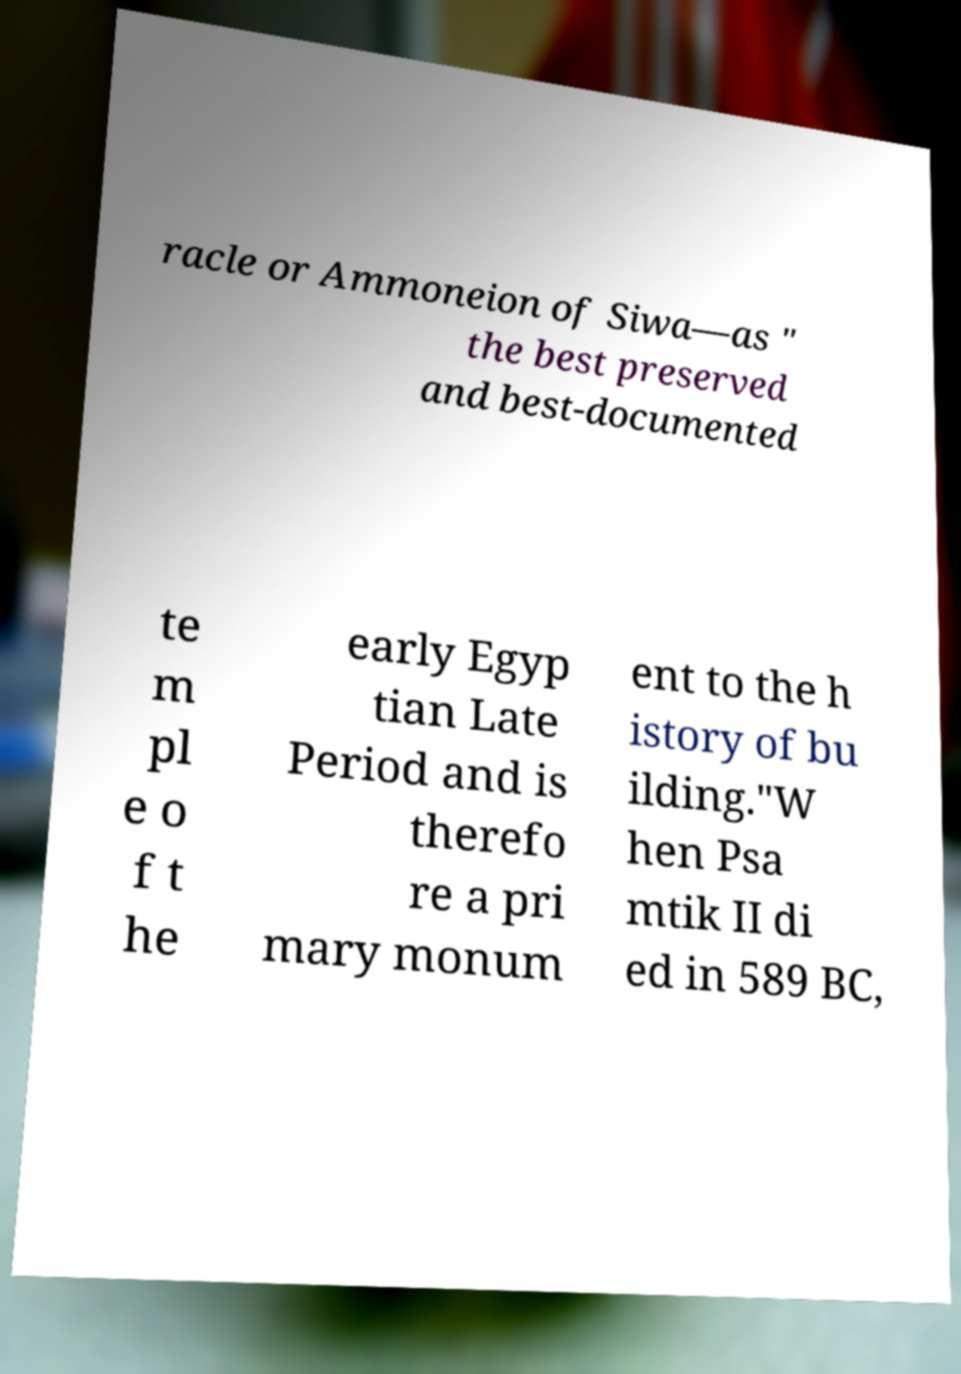Could you assist in decoding the text presented in this image and type it out clearly? racle or Ammoneion of Siwa—as " the best preserved and best-documented te m pl e o f t he early Egyp tian Late Period and is therefo re a pri mary monum ent to the h istory of bu ilding."W hen Psa mtik II di ed in 589 BC, 